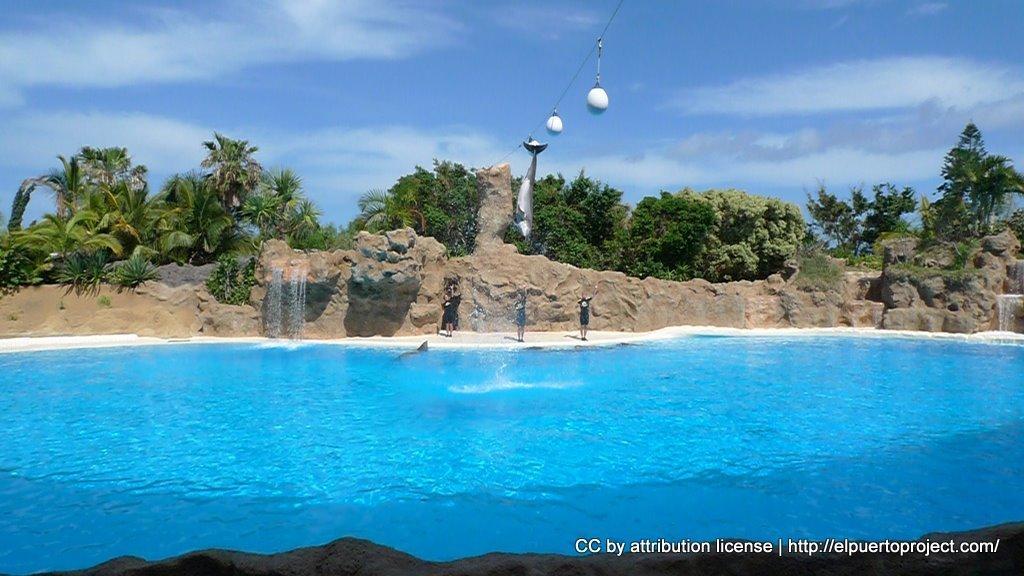In one or two sentences, can you explain what this image depicts? In this image there is water. In the back there are few people are standing. And there is a fish and rope with balls. In the background there is a wall, trees and sky with clouds. Also there is a waterfall through the rocks. At the bottom something is written on the image. 